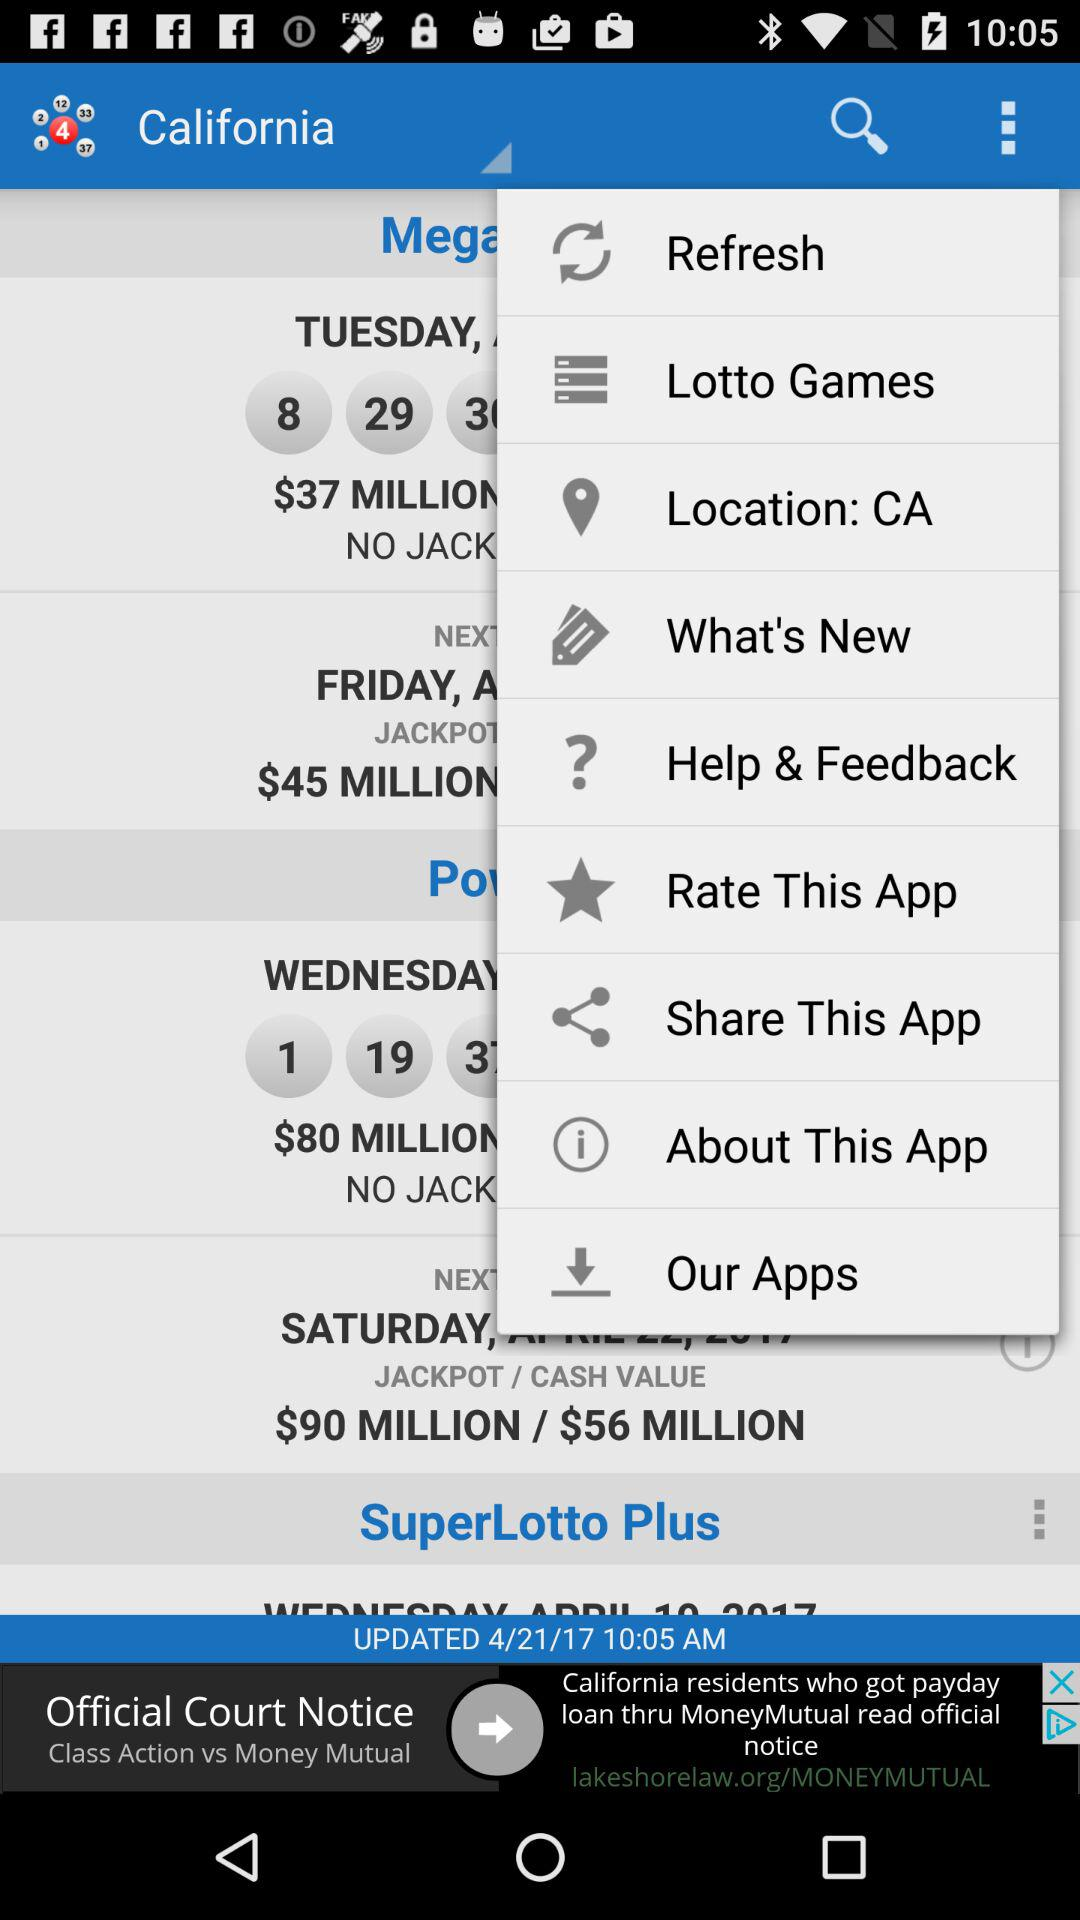What is the date of the update? The date of the update is April 21, 2017. 